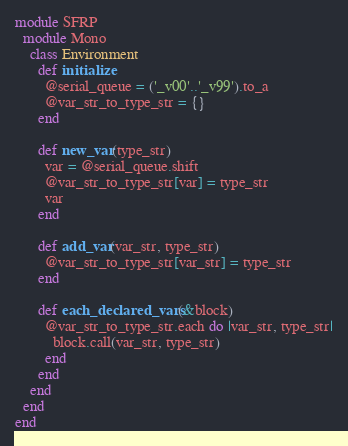Convert code to text. <code><loc_0><loc_0><loc_500><loc_500><_Ruby_>module SFRP
  module Mono
    class Environment
      def initialize
        @serial_queue = ('_v00'..'_v99').to_a
        @var_str_to_type_str = {}
      end

      def new_var(type_str)
        var = @serial_queue.shift
        @var_str_to_type_str[var] = type_str
        var
      end

      def add_var(var_str, type_str)
        @var_str_to_type_str[var_str] = type_str
      end

      def each_declared_vars(&block)
        @var_str_to_type_str.each do |var_str, type_str|
          block.call(var_str, type_str)
        end
      end
    end
  end
end
</code> 